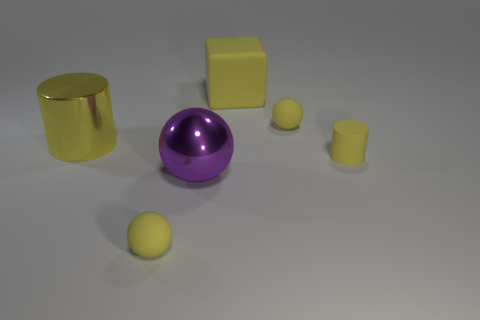There is a purple object that is the same size as the yellow metallic cylinder; what material is it?
Provide a short and direct response. Metal. The small sphere behind the small yellow rubber thing left of the metal ball is what color?
Keep it short and to the point. Yellow. What number of matte cylinders are to the left of the large yellow rubber object?
Your answer should be very brief. 0. The matte block is what color?
Provide a short and direct response. Yellow. How many small objects are rubber spheres or yellow matte things?
Make the answer very short. 3. Does the cylinder that is on the left side of the large ball have the same color as the tiny ball that is behind the yellow metal thing?
Offer a terse response. Yes. What number of other objects are there of the same color as the rubber cylinder?
Provide a short and direct response. 4. The tiny thing that is in front of the big metallic ball has what shape?
Your answer should be compact. Sphere. Are there fewer large metallic cylinders than small purple metal blocks?
Ensure brevity in your answer.  No. Do the yellow sphere that is behind the small yellow rubber cylinder and the big block have the same material?
Make the answer very short. Yes. 